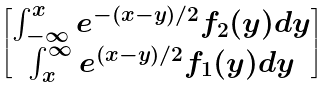Convert formula to latex. <formula><loc_0><loc_0><loc_500><loc_500>\begin{bmatrix} \int ^ { x } _ { - \infty } e ^ { - ( x - y ) / 2 } f _ { 2 } ( y ) d y \\ \int _ { x } ^ { \infty } e ^ { ( x - y ) / 2 } f _ { 1 } ( y ) d y \end{bmatrix}</formula> 